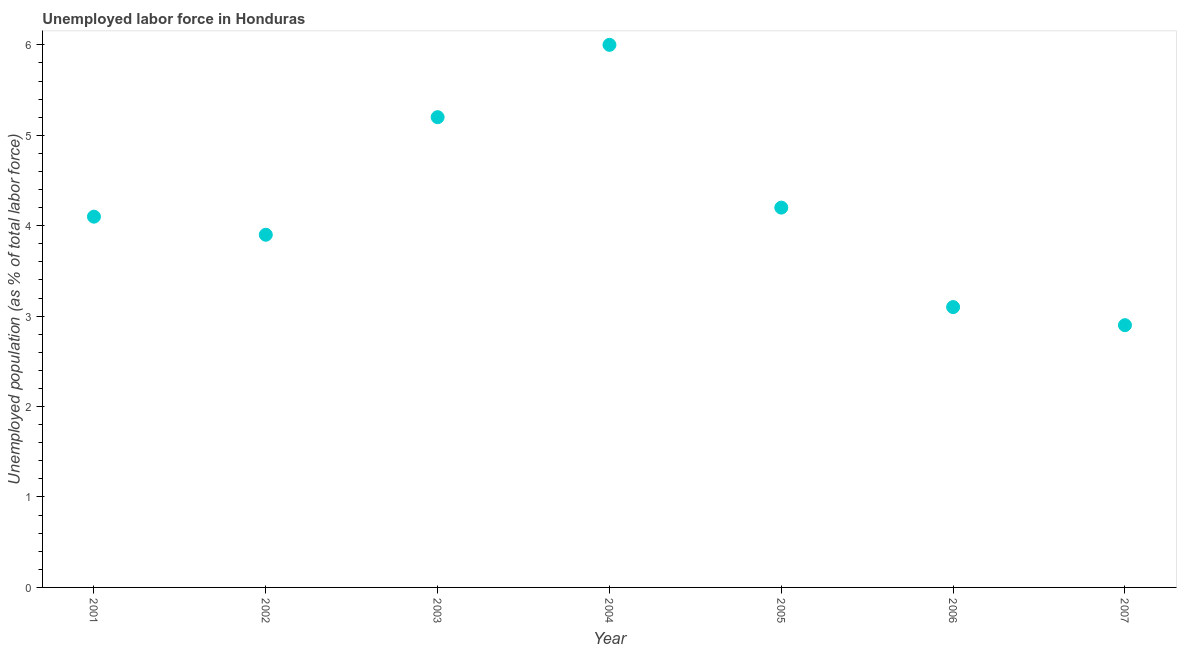What is the total unemployed population in 2006?
Your answer should be very brief. 3.1. Across all years, what is the minimum total unemployed population?
Your answer should be compact. 2.9. In which year was the total unemployed population maximum?
Your answer should be very brief. 2004. What is the sum of the total unemployed population?
Ensure brevity in your answer.  29.4. What is the difference between the total unemployed population in 2002 and 2004?
Your response must be concise. -2.1. What is the average total unemployed population per year?
Your answer should be very brief. 4.2. What is the median total unemployed population?
Keep it short and to the point. 4.1. Do a majority of the years between 2005 and 2006 (inclusive) have total unemployed population greater than 4 %?
Offer a terse response. No. What is the ratio of the total unemployed population in 2003 to that in 2005?
Offer a very short reply. 1.24. Is the total unemployed population in 2001 less than that in 2003?
Your answer should be compact. Yes. What is the difference between the highest and the second highest total unemployed population?
Offer a very short reply. 0.8. Is the sum of the total unemployed population in 2006 and 2007 greater than the maximum total unemployed population across all years?
Provide a succinct answer. No. What is the difference between the highest and the lowest total unemployed population?
Offer a terse response. 3.1. Does the total unemployed population monotonically increase over the years?
Make the answer very short. No. What is the difference between two consecutive major ticks on the Y-axis?
Provide a succinct answer. 1. What is the title of the graph?
Give a very brief answer. Unemployed labor force in Honduras. What is the label or title of the X-axis?
Keep it short and to the point. Year. What is the label or title of the Y-axis?
Keep it short and to the point. Unemployed population (as % of total labor force). What is the Unemployed population (as % of total labor force) in 2001?
Make the answer very short. 4.1. What is the Unemployed population (as % of total labor force) in 2002?
Ensure brevity in your answer.  3.9. What is the Unemployed population (as % of total labor force) in 2003?
Keep it short and to the point. 5.2. What is the Unemployed population (as % of total labor force) in 2004?
Provide a short and direct response. 6. What is the Unemployed population (as % of total labor force) in 2005?
Give a very brief answer. 4.2. What is the Unemployed population (as % of total labor force) in 2006?
Make the answer very short. 3.1. What is the Unemployed population (as % of total labor force) in 2007?
Make the answer very short. 2.9. What is the difference between the Unemployed population (as % of total labor force) in 2001 and 2003?
Your answer should be very brief. -1.1. What is the difference between the Unemployed population (as % of total labor force) in 2001 and 2004?
Offer a terse response. -1.9. What is the difference between the Unemployed population (as % of total labor force) in 2001 and 2005?
Keep it short and to the point. -0.1. What is the difference between the Unemployed population (as % of total labor force) in 2002 and 2004?
Provide a succinct answer. -2.1. What is the difference between the Unemployed population (as % of total labor force) in 2002 and 2007?
Offer a terse response. 1. What is the difference between the Unemployed population (as % of total labor force) in 2003 and 2006?
Offer a very short reply. 2.1. What is the difference between the Unemployed population (as % of total labor force) in 2003 and 2007?
Provide a short and direct response. 2.3. What is the difference between the Unemployed population (as % of total labor force) in 2004 and 2005?
Give a very brief answer. 1.8. What is the difference between the Unemployed population (as % of total labor force) in 2004 and 2006?
Your answer should be very brief. 2.9. What is the difference between the Unemployed population (as % of total labor force) in 2004 and 2007?
Offer a terse response. 3.1. What is the difference between the Unemployed population (as % of total labor force) in 2005 and 2006?
Keep it short and to the point. 1.1. What is the difference between the Unemployed population (as % of total labor force) in 2005 and 2007?
Offer a very short reply. 1.3. What is the ratio of the Unemployed population (as % of total labor force) in 2001 to that in 2002?
Keep it short and to the point. 1.05. What is the ratio of the Unemployed population (as % of total labor force) in 2001 to that in 2003?
Make the answer very short. 0.79. What is the ratio of the Unemployed population (as % of total labor force) in 2001 to that in 2004?
Offer a very short reply. 0.68. What is the ratio of the Unemployed population (as % of total labor force) in 2001 to that in 2006?
Provide a short and direct response. 1.32. What is the ratio of the Unemployed population (as % of total labor force) in 2001 to that in 2007?
Give a very brief answer. 1.41. What is the ratio of the Unemployed population (as % of total labor force) in 2002 to that in 2003?
Your answer should be compact. 0.75. What is the ratio of the Unemployed population (as % of total labor force) in 2002 to that in 2004?
Provide a short and direct response. 0.65. What is the ratio of the Unemployed population (as % of total labor force) in 2002 to that in 2005?
Give a very brief answer. 0.93. What is the ratio of the Unemployed population (as % of total labor force) in 2002 to that in 2006?
Give a very brief answer. 1.26. What is the ratio of the Unemployed population (as % of total labor force) in 2002 to that in 2007?
Provide a short and direct response. 1.34. What is the ratio of the Unemployed population (as % of total labor force) in 2003 to that in 2004?
Your answer should be very brief. 0.87. What is the ratio of the Unemployed population (as % of total labor force) in 2003 to that in 2005?
Offer a very short reply. 1.24. What is the ratio of the Unemployed population (as % of total labor force) in 2003 to that in 2006?
Your answer should be very brief. 1.68. What is the ratio of the Unemployed population (as % of total labor force) in 2003 to that in 2007?
Your response must be concise. 1.79. What is the ratio of the Unemployed population (as % of total labor force) in 2004 to that in 2005?
Give a very brief answer. 1.43. What is the ratio of the Unemployed population (as % of total labor force) in 2004 to that in 2006?
Give a very brief answer. 1.94. What is the ratio of the Unemployed population (as % of total labor force) in 2004 to that in 2007?
Keep it short and to the point. 2.07. What is the ratio of the Unemployed population (as % of total labor force) in 2005 to that in 2006?
Keep it short and to the point. 1.35. What is the ratio of the Unemployed population (as % of total labor force) in 2005 to that in 2007?
Give a very brief answer. 1.45. What is the ratio of the Unemployed population (as % of total labor force) in 2006 to that in 2007?
Provide a short and direct response. 1.07. 